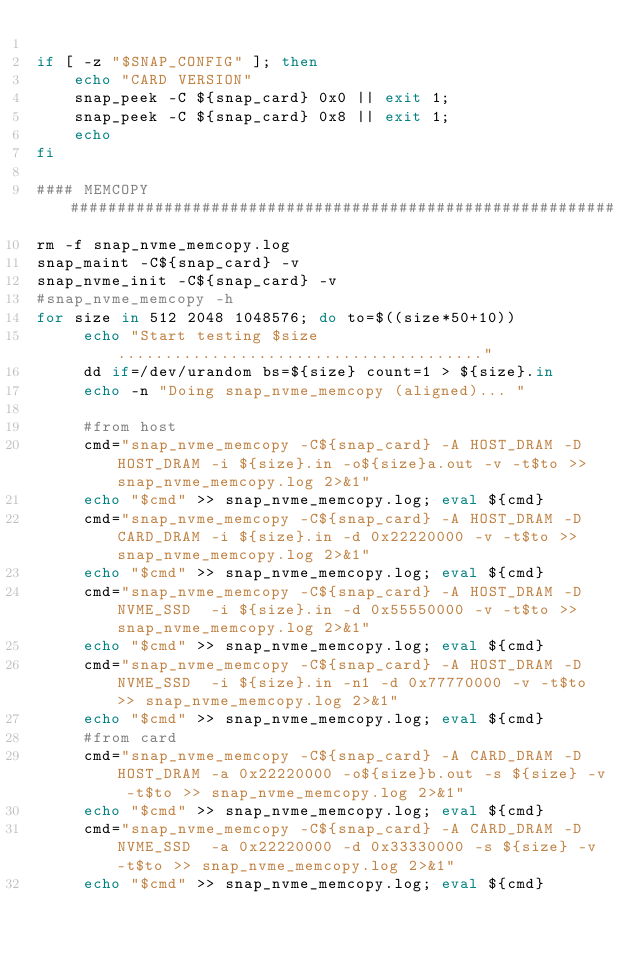Convert code to text. <code><loc_0><loc_0><loc_500><loc_500><_Bash_>
if [ -z "$SNAP_CONFIG" ]; then
	echo "CARD VERSION"
	snap_peek -C ${snap_card} 0x0 || exit 1;
	snap_peek -C ${snap_card} 0x8 || exit 1;
	echo
fi

#### MEMCOPY ##########################################################
rm -f snap_nvme_memcopy.log
snap_maint -C${snap_card} -v
snap_nvme_init -C${snap_card} -v
#snap_nvme_memcopy -h
for size in 512 2048 1048576; do to=$((size*50+10))
     echo "Start testing $size......................................."
     dd if=/dev/urandom bs=${size} count=1 > ${size}.in
     echo -n "Doing snap_nvme_memcopy (aligned)... "
   
     #from host
     cmd="snap_nvme_memcopy -C${snap_card} -A HOST_DRAM -D HOST_DRAM -i ${size}.in -o${size}a.out -v -t$to >> snap_nvme_memcopy.log 2>&1" 
     echo "$cmd" >> snap_nvme_memcopy.log; eval ${cmd}
     cmd="snap_nvme_memcopy -C${snap_card} -A HOST_DRAM -D CARD_DRAM -i ${size}.in -d 0x22220000 -v -t$to >> snap_nvme_memcopy.log 2>&1" 
     echo "$cmd" >> snap_nvme_memcopy.log; eval ${cmd}
     cmd="snap_nvme_memcopy -C${snap_card} -A HOST_DRAM -D NVME_SSD  -i ${size}.in -d 0x55550000 -v -t$to >> snap_nvme_memcopy.log 2>&1" 
     echo "$cmd" >> snap_nvme_memcopy.log; eval ${cmd}
     cmd="snap_nvme_memcopy -C${snap_card} -A HOST_DRAM -D NVME_SSD  -i ${size}.in -n1 -d 0x77770000 -v -t$to >> snap_nvme_memcopy.log 2>&1" 
     echo "$cmd" >> snap_nvme_memcopy.log; eval ${cmd}
     #from card
     cmd="snap_nvme_memcopy -C${snap_card} -A CARD_DRAM -D HOST_DRAM -a 0x22220000 -o${size}b.out -s ${size} -v -t$to >> snap_nvme_memcopy.log 2>&1" 
     echo "$cmd" >> snap_nvme_memcopy.log; eval ${cmd}
     cmd="snap_nvme_memcopy -C${snap_card} -A CARD_DRAM -D NVME_SSD  -a 0x22220000 -d 0x33330000 -s ${size} -v -t$to >> snap_nvme_memcopy.log 2>&1" 
     echo "$cmd" >> snap_nvme_memcopy.log; eval ${cmd}</code> 